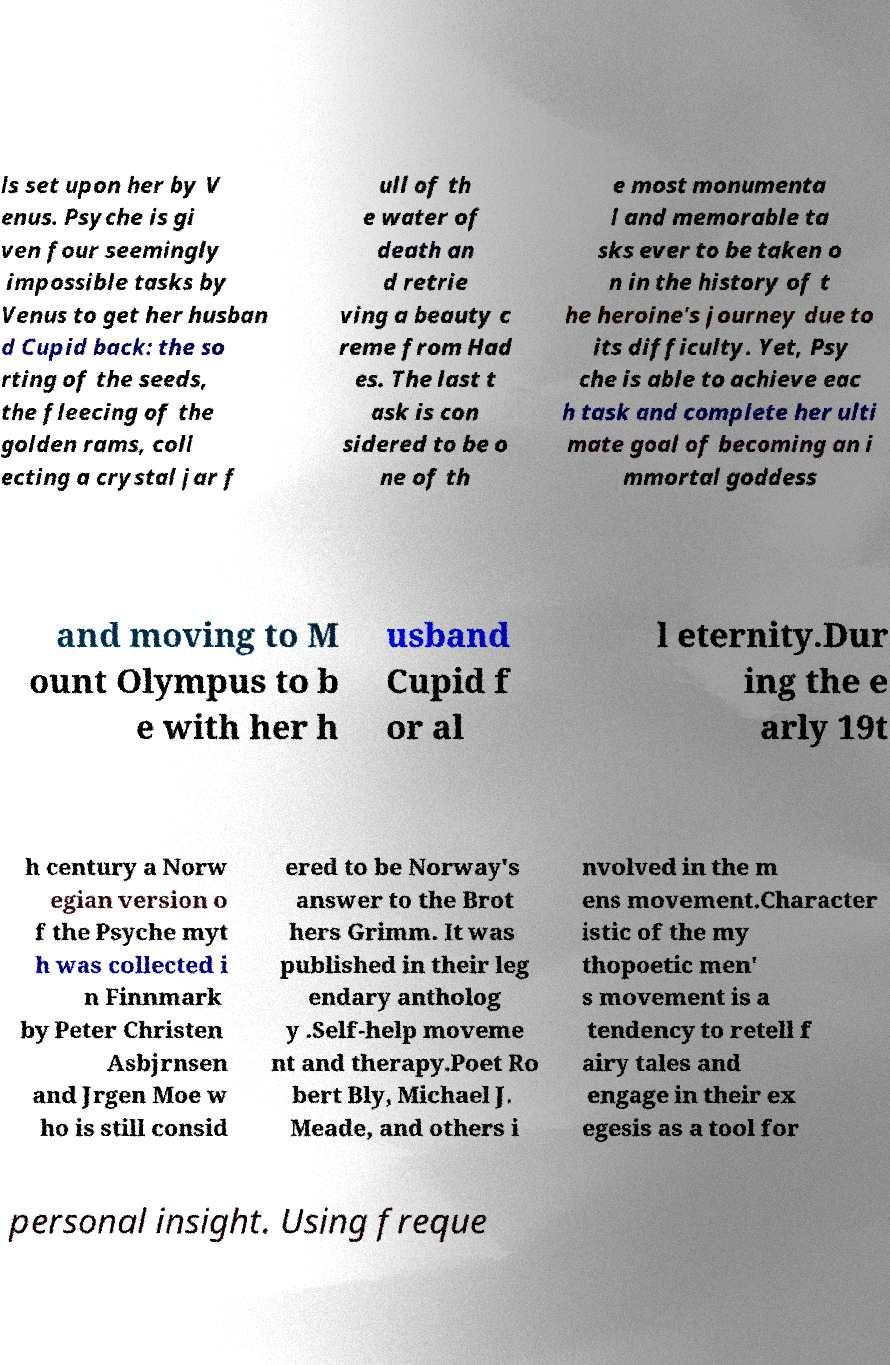Please identify and transcribe the text found in this image. ls set upon her by V enus. Psyche is gi ven four seemingly impossible tasks by Venus to get her husban d Cupid back: the so rting of the seeds, the fleecing of the golden rams, coll ecting a crystal jar f ull of th e water of death an d retrie ving a beauty c reme from Had es. The last t ask is con sidered to be o ne of th e most monumenta l and memorable ta sks ever to be taken o n in the history of t he heroine's journey due to its difficulty. Yet, Psy che is able to achieve eac h task and complete her ulti mate goal of becoming an i mmortal goddess and moving to M ount Olympus to b e with her h usband Cupid f or al l eternity.Dur ing the e arly 19t h century a Norw egian version o f the Psyche myt h was collected i n Finnmark by Peter Christen Asbjrnsen and Jrgen Moe w ho is still consid ered to be Norway's answer to the Brot hers Grimm. It was published in their leg endary antholog y .Self-help moveme nt and therapy.Poet Ro bert Bly, Michael J. Meade, and others i nvolved in the m ens movement.Character istic of the my thopoetic men' s movement is a tendency to retell f airy tales and engage in their ex egesis as a tool for personal insight. Using freque 